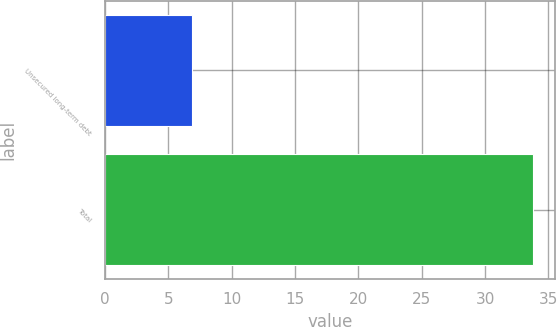Convert chart to OTSL. <chart><loc_0><loc_0><loc_500><loc_500><bar_chart><fcel>Unsecured long-term debt<fcel>Total<nl><fcel>6.9<fcel>33.8<nl></chart> 